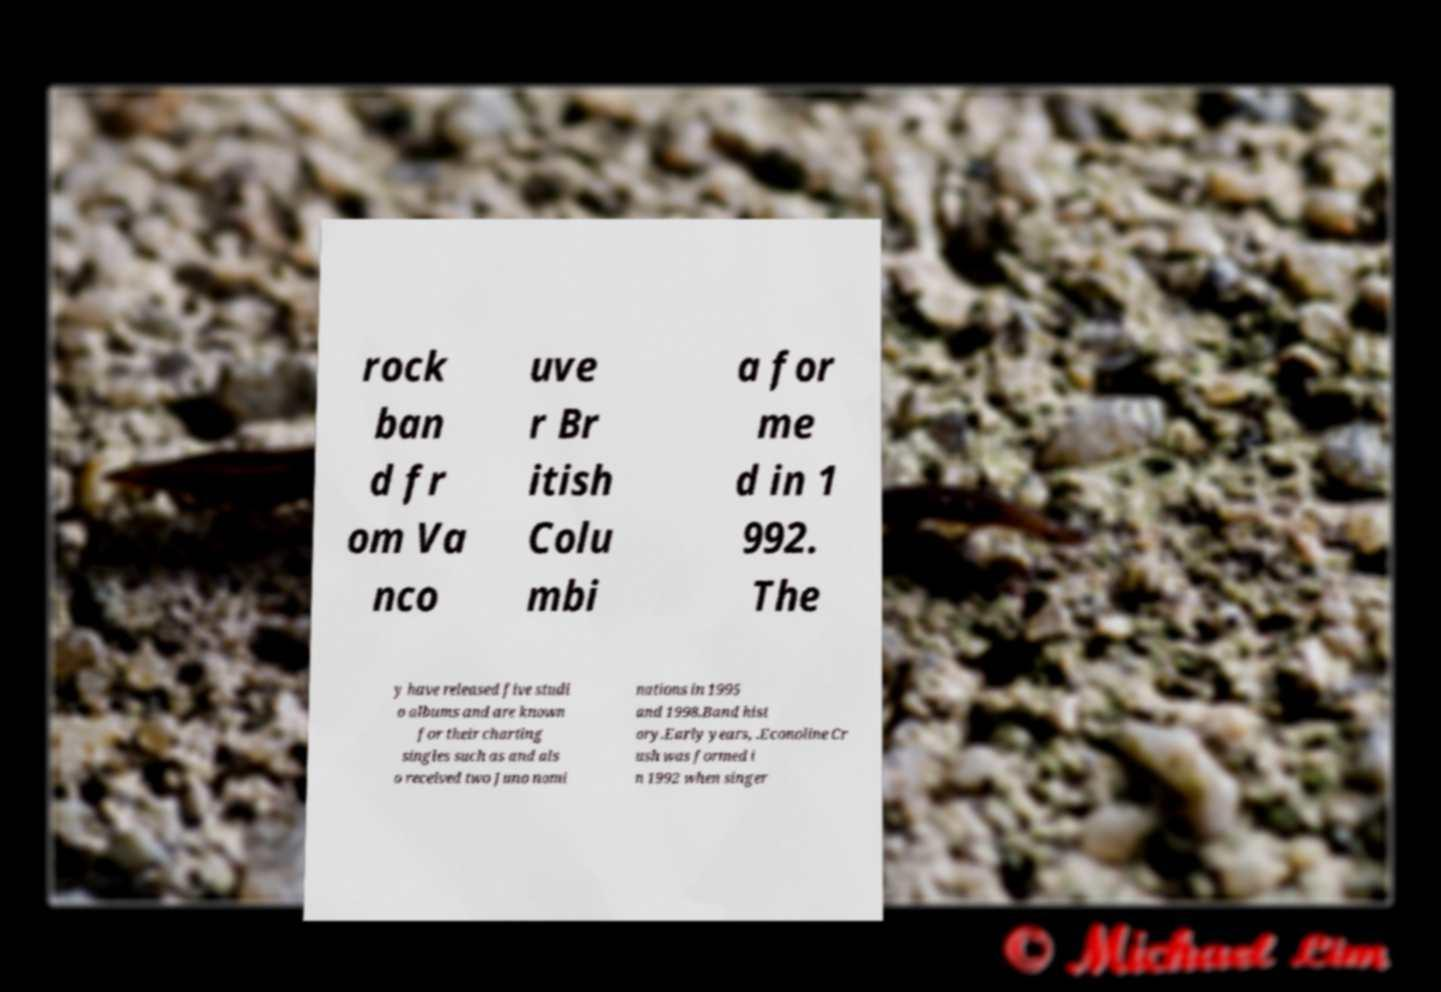Could you assist in decoding the text presented in this image and type it out clearly? rock ban d fr om Va nco uve r Br itish Colu mbi a for me d in 1 992. The y have released five studi o albums and are known for their charting singles such as and als o received two Juno nomi nations in 1995 and 1998.Band hist ory.Early years, .Econoline Cr ush was formed i n 1992 when singer 